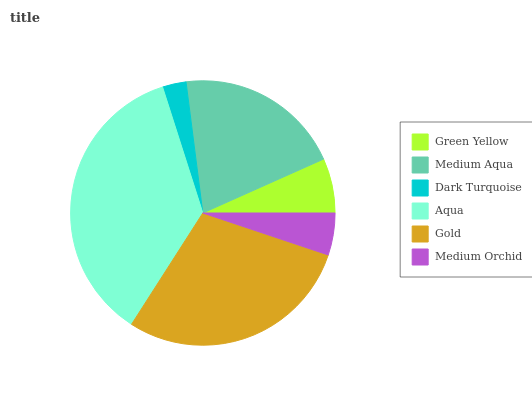Is Dark Turquoise the minimum?
Answer yes or no. Yes. Is Aqua the maximum?
Answer yes or no. Yes. Is Medium Aqua the minimum?
Answer yes or no. No. Is Medium Aqua the maximum?
Answer yes or no. No. Is Medium Aqua greater than Green Yellow?
Answer yes or no. Yes. Is Green Yellow less than Medium Aqua?
Answer yes or no. Yes. Is Green Yellow greater than Medium Aqua?
Answer yes or no. No. Is Medium Aqua less than Green Yellow?
Answer yes or no. No. Is Medium Aqua the high median?
Answer yes or no. Yes. Is Green Yellow the low median?
Answer yes or no. Yes. Is Dark Turquoise the high median?
Answer yes or no. No. Is Aqua the low median?
Answer yes or no. No. 